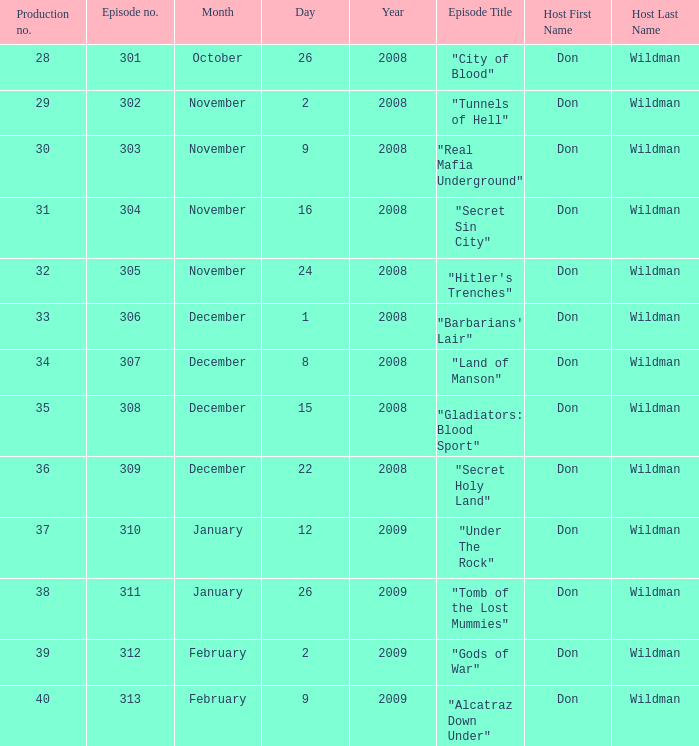What is the episode number of the episode that originally aired on January 26, 2009 and had a production number smaller than 38? 0.0. 